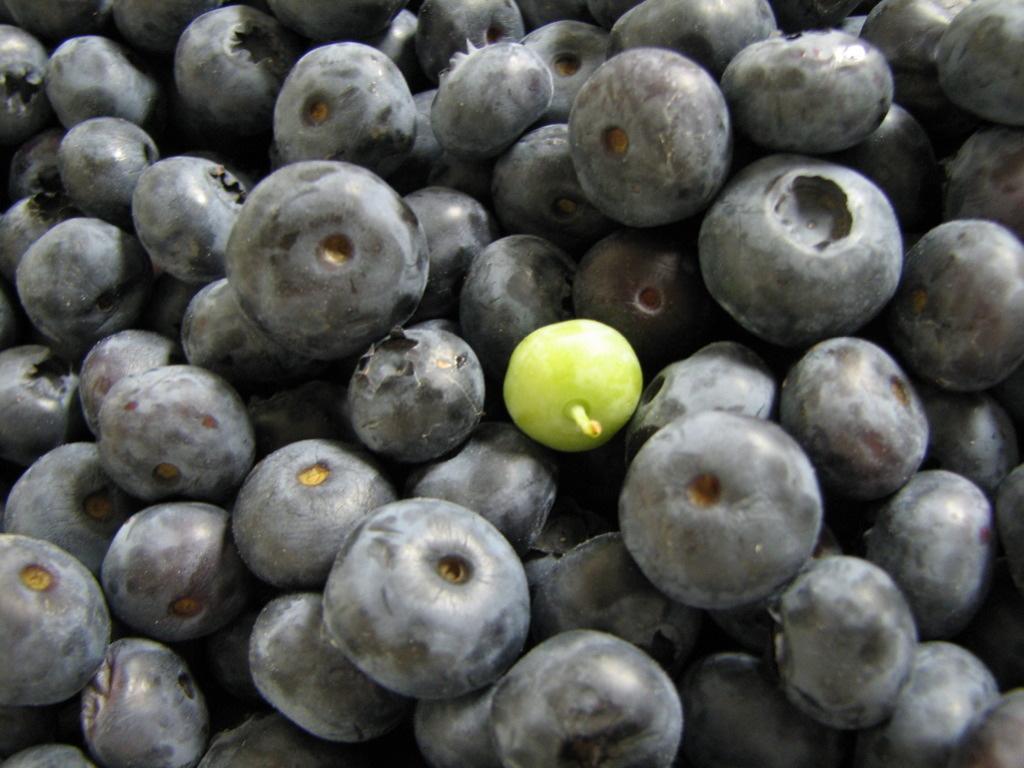Can you describe this image briefly? In this image I can see few black and green color fruits. 